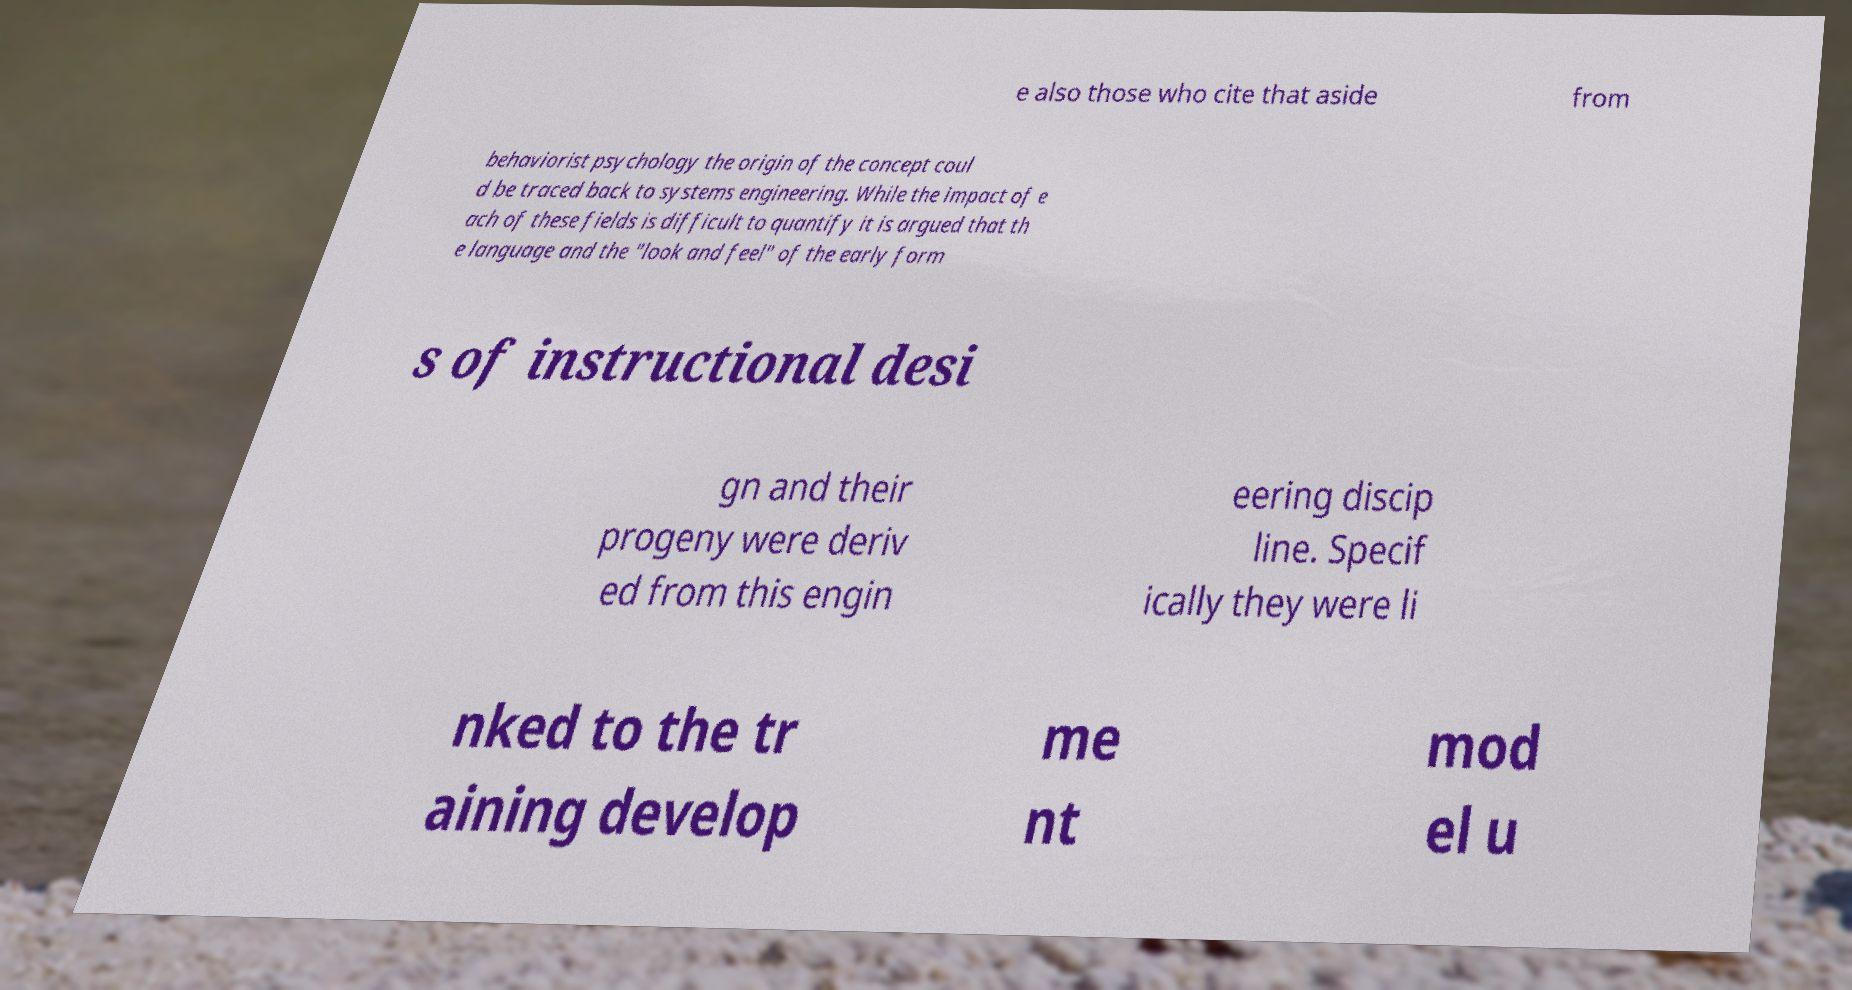Can you read and provide the text displayed in the image?This photo seems to have some interesting text. Can you extract and type it out for me? e also those who cite that aside from behaviorist psychology the origin of the concept coul d be traced back to systems engineering. While the impact of e ach of these fields is difficult to quantify it is argued that th e language and the "look and feel" of the early form s of instructional desi gn and their progeny were deriv ed from this engin eering discip line. Specif ically they were li nked to the tr aining develop me nt mod el u 